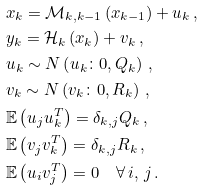<formula> <loc_0><loc_0><loc_500><loc_500>& x _ { k } = \mathcal { M } _ { k , k - 1 } \left ( x _ { k - 1 } \right ) + u _ { k } \, , \\ & y _ { k } = \mathcal { H } _ { k } \left ( x _ { k } \right ) + v _ { k } \, , \\ & u _ { k } \sim N \left ( u _ { k } \colon 0 , Q _ { k } \right ) \, , \\ & v _ { k } \sim N \left ( v _ { k } \colon 0 , R _ { k } \right ) \, , \\ & \mathbb { E } \left ( u _ { j } u _ { k } ^ { T } \right ) = \delta _ { k , j } Q _ { k } \, , \\ & \mathbb { E } \left ( v _ { j } v _ { k } ^ { T } \right ) = \delta _ { k , j } R _ { k } \, , \\ & \mathbb { E } \left ( u _ { i } v _ { j } ^ { T } \right ) = 0 \quad \forall \, i , \, j \, .</formula> 